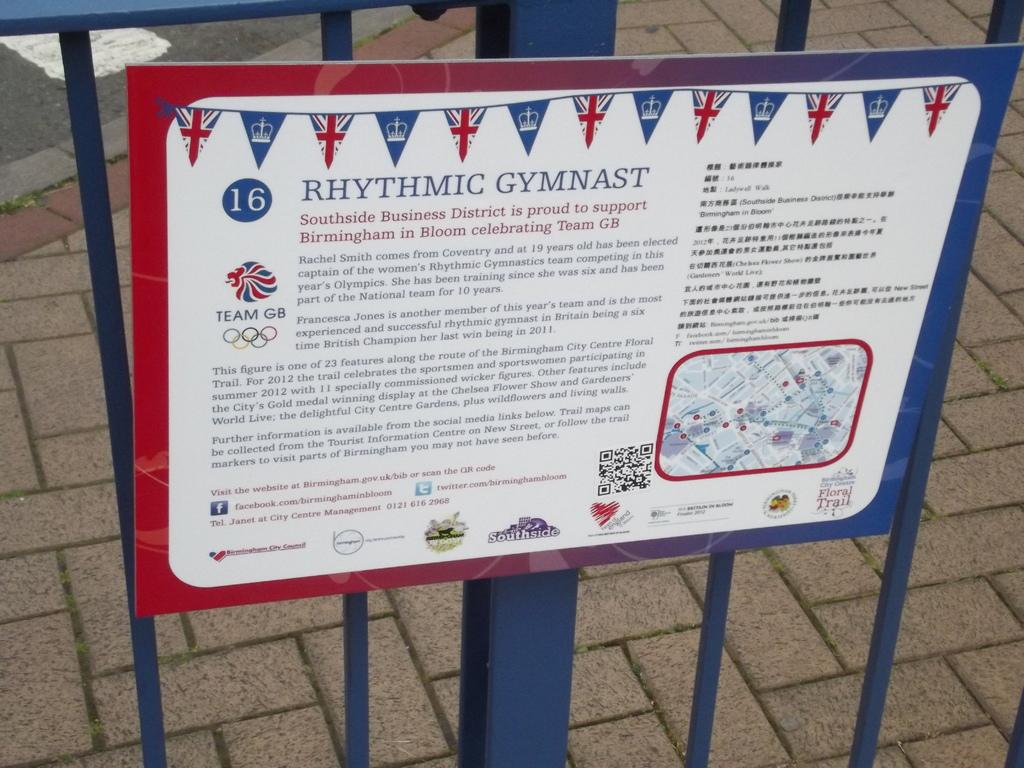<image>
Summarize the visual content of the image. A metal sign saying Rhythmic Gymnast attached to a blue metal fence. 